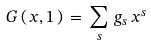<formula> <loc_0><loc_0><loc_500><loc_500>G \, ( \, x , 1 \, ) \, = \, \sum _ { s } \, g _ { s } \, x ^ { s }</formula> 